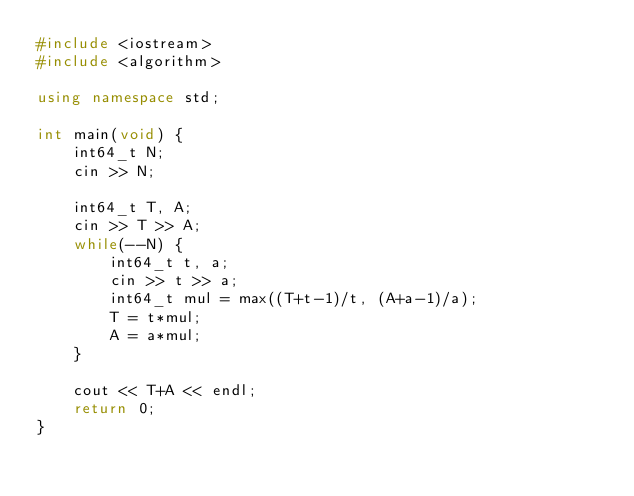Convert code to text. <code><loc_0><loc_0><loc_500><loc_500><_C++_>#include <iostream>
#include <algorithm>

using namespace std;

int main(void) {
    int64_t N;
    cin >> N;

    int64_t T, A;
    cin >> T >> A;
    while(--N) {
        int64_t t, a;
        cin >> t >> a;
        int64_t mul = max((T+t-1)/t, (A+a-1)/a);
        T = t*mul;
        A = a*mul;
    }

    cout << T+A << endl;
    return 0;
}
</code> 